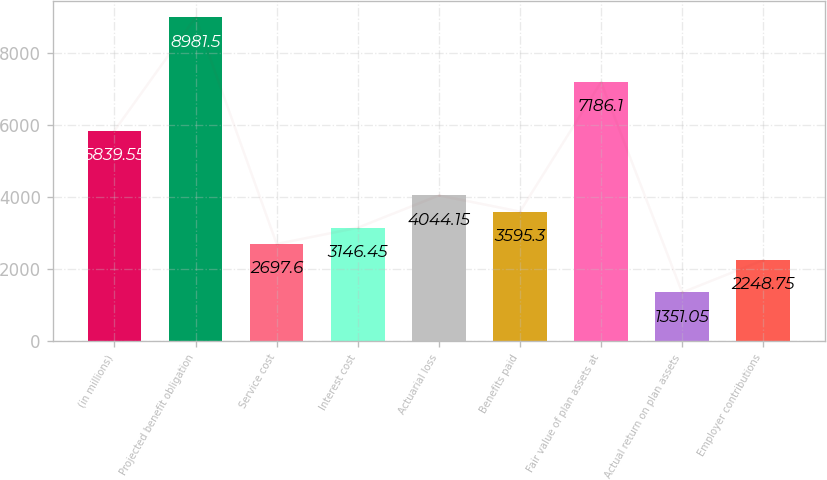<chart> <loc_0><loc_0><loc_500><loc_500><bar_chart><fcel>(in millions)<fcel>Projected benefit obligation<fcel>Service cost<fcel>Interest cost<fcel>Actuarial loss<fcel>Benefits paid<fcel>Fair value of plan assets at<fcel>Actual return on plan assets<fcel>Employer contributions<nl><fcel>5839.55<fcel>8981.5<fcel>2697.6<fcel>3146.45<fcel>4044.15<fcel>3595.3<fcel>7186.1<fcel>1351.05<fcel>2248.75<nl></chart> 